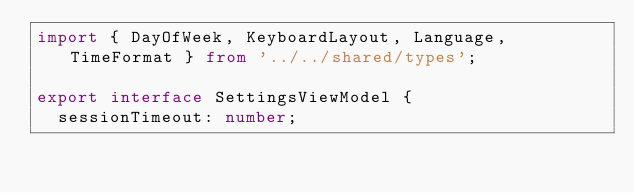Convert code to text. <code><loc_0><loc_0><loc_500><loc_500><_TypeScript_>import { DayOfWeek, KeyboardLayout, Language, TimeFormat } from '../../shared/types';

export interface SettingsViewModel {
  sessionTimeout: number;</code> 